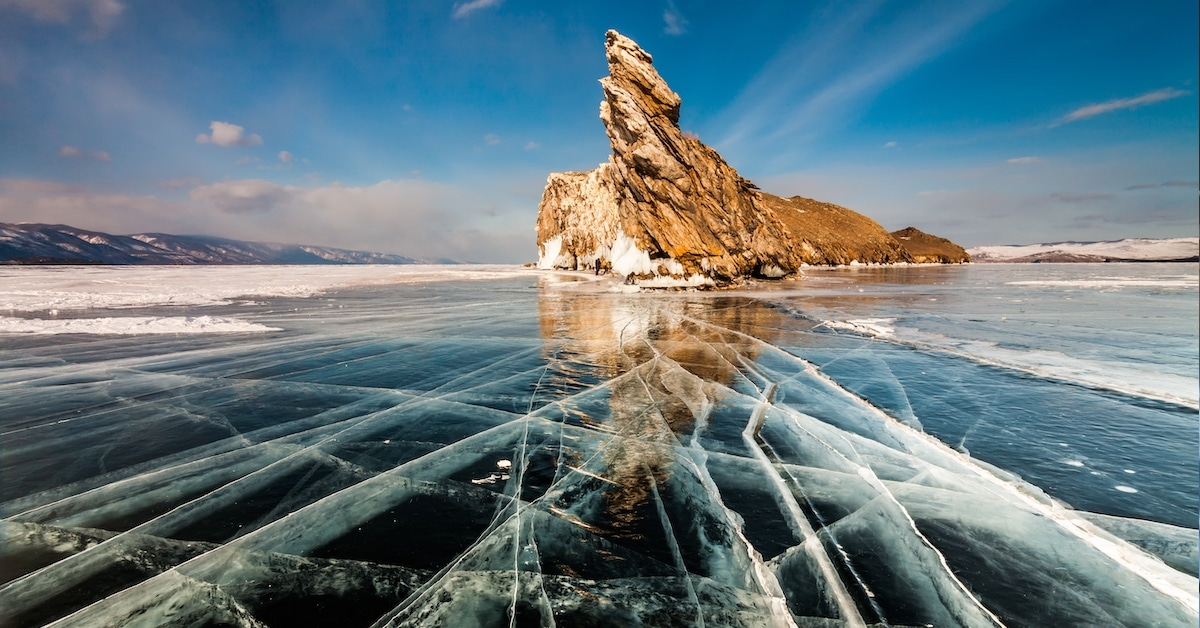What cultural or historical significance does this place hold? Lake Baikal holds deep cultural and historical significance, particularly for the indigenous Buryat tribes and other local communities. It is considered a spiritual center, and many myths and legends are associated with it. Shaman Rock, visible in the image, is a particularly sacred site where rituals and ceremonies have been performed for generations, believed to be a dwelling of spirits. In more recent history, the lake has also been a crucial study area for scientists and historians, contributing significantly to the natural and cultural heritage of Siberia and Russia as a whole. 